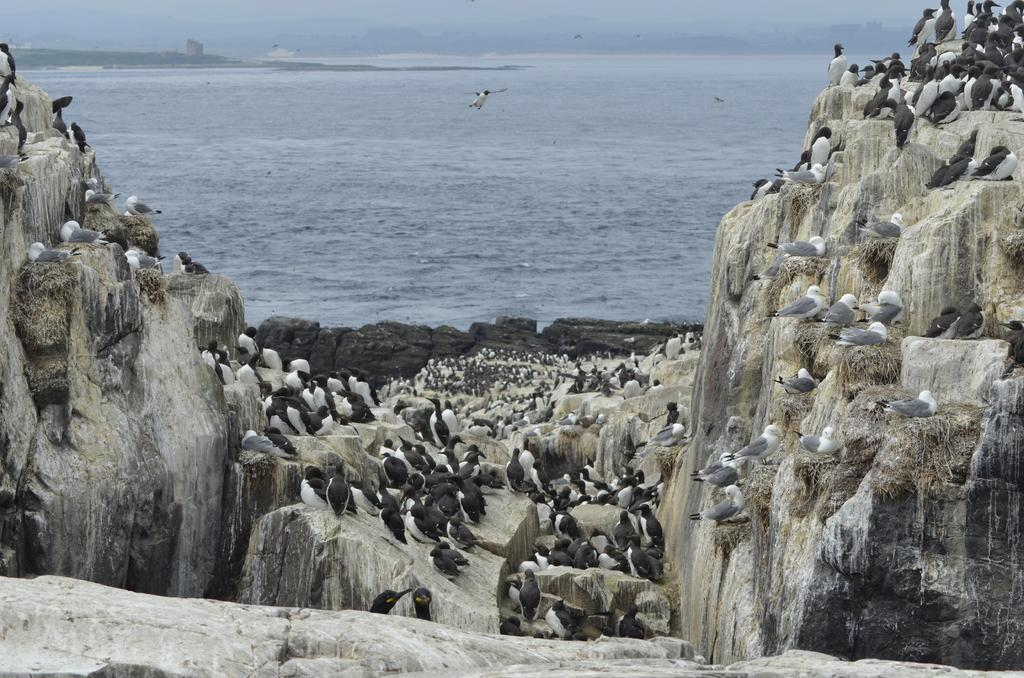What animals can be seen on the rocks in the image? There are penguins on the rocks in the image. What geographical features are present on either side of the image? There are two hills on either side of the image. What body of water can be seen in the background of the image? There is an ocean visible in the background of the image. What type of shirt is the penguin wearing in the image? Penguins do not wear shirts, and there are no shirts present in the image. 